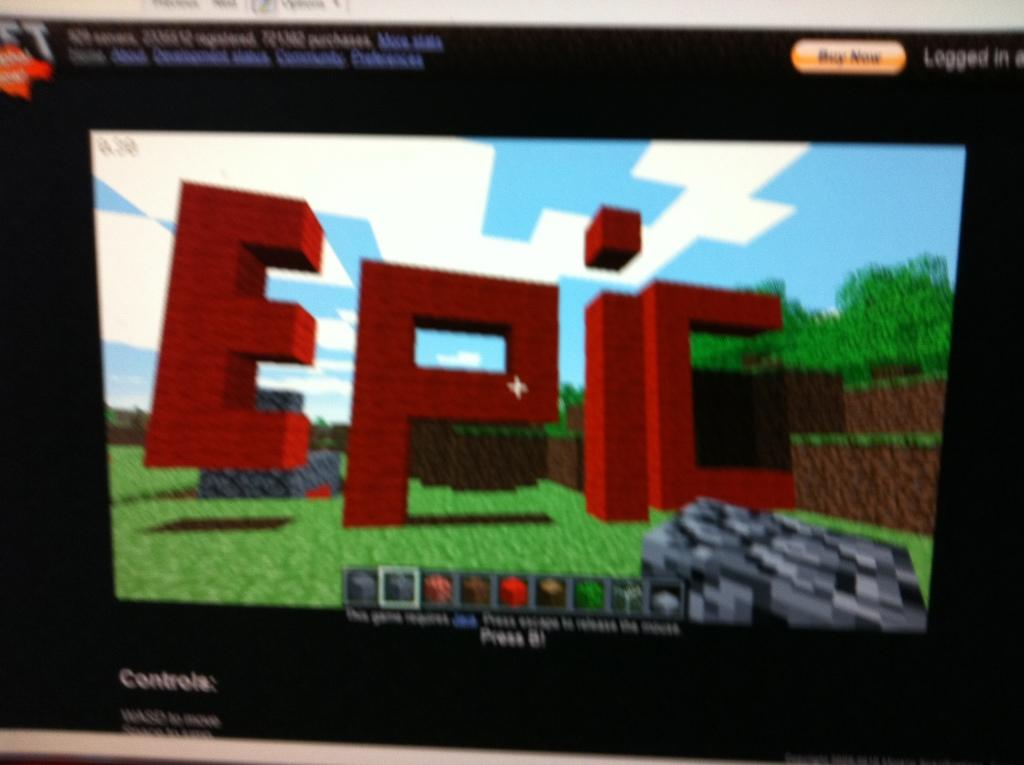What is the value of the apple that the deer is holding in the image? There is no image provided, and therefore no deer or apple can be observed. Consequently, it is impossible to determine the value of an apple that is not present. 